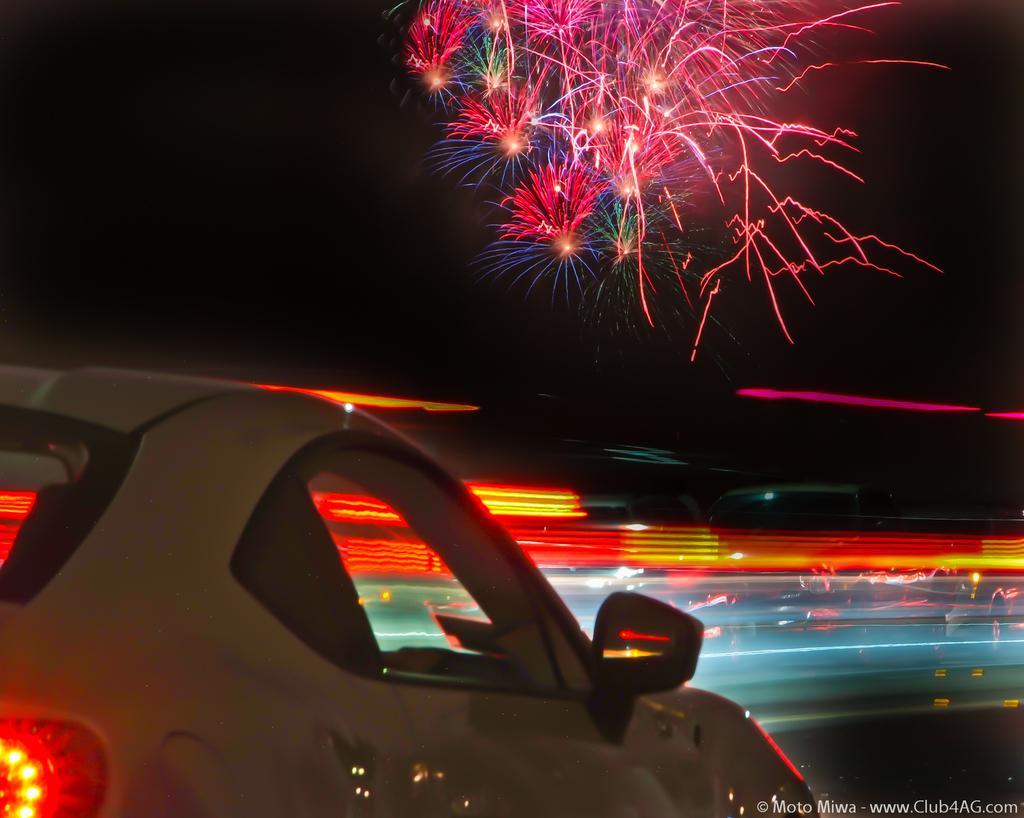Please provide a concise description of this image. In this picture we can see some crackers lighting and few vehicles are moving on the road. 